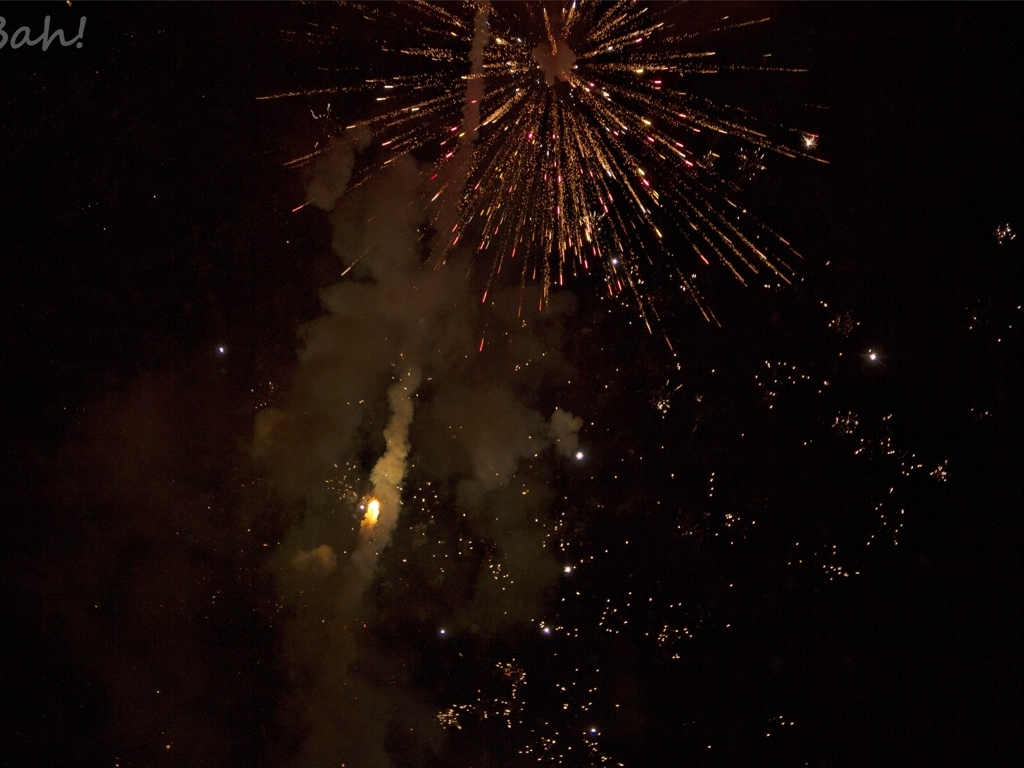Could this image be from a professional fireworks show? Based on the scale and intensity of the fireworks, it certainly seems like a professional display, designed to captivate an audience with a spectacular array of bursts and patterns. What technical settings might have been used to capture this image? To capture the dynamic range and motion of fireworks at night, a slow shutter speed, along with a low ISO to prevent overexposure and a wider aperture, would likely have been utilized in the camera's settings. 